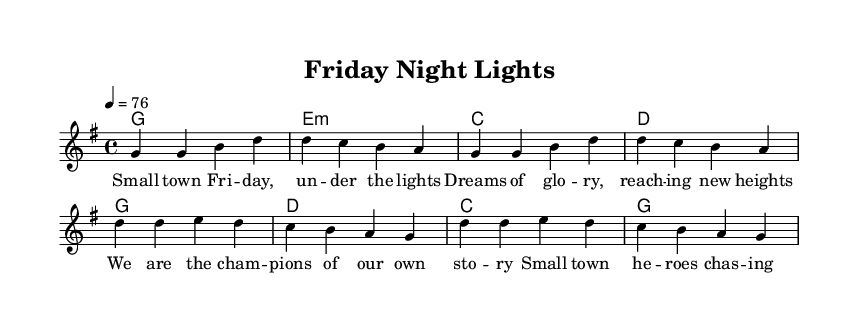What is the key signature of this music? The key signature is G major, which includes one sharp (F#). You can identify the key signature at the beginning of the staff; it shows one sharp, indicating G major.
Answer: G major What is the time signature of this music? The time signature is 4/4, which indicates that there are four beats in each measure and the quarter note gets one beat. This can be found at the beginning of the music, right after the key signature.
Answer: 4/4 What is the tempo marking for this piece? The tempo marking is 76 beats per minute, which indicates how fast the piece should be played. This is represented next to the tempo indication (4 = 76) at the beginning of the music.
Answer: 76 How many measures are in the verse before the chorus begins? There are four measures in the verse. By counting the measures specified in the melody section (g4 g b d to g g b d), we find that the first four measures belong to the verse before reaching the chorus.
Answer: 4 What are the lyrics for the first line of the verse? The first line of the verse contains the lyrics “Small town Friday, under the lights.” By looking at the lyrics section aligned with the melody, we see the first part corresponds to this specific line.
Answer: Small town Friday, under the lights What is the first chord played in the verse? The first chord played in the verse is G major, which is indicated at the beginning of the verse section of the harmonies. The first symbol in the chord progression is G, confirming this.
Answer: G How does the chorus reflect the theme of small-town sports dreams? The chorus lyrics state that “We are the champions of our own story” and “Small town heroes chasing the glory,” which directly evokes the aspirations of sports dreams in a local context. The wording reflects themes of pride and ambition typical in small-town life.
Answer: Champions, heroes, glory 